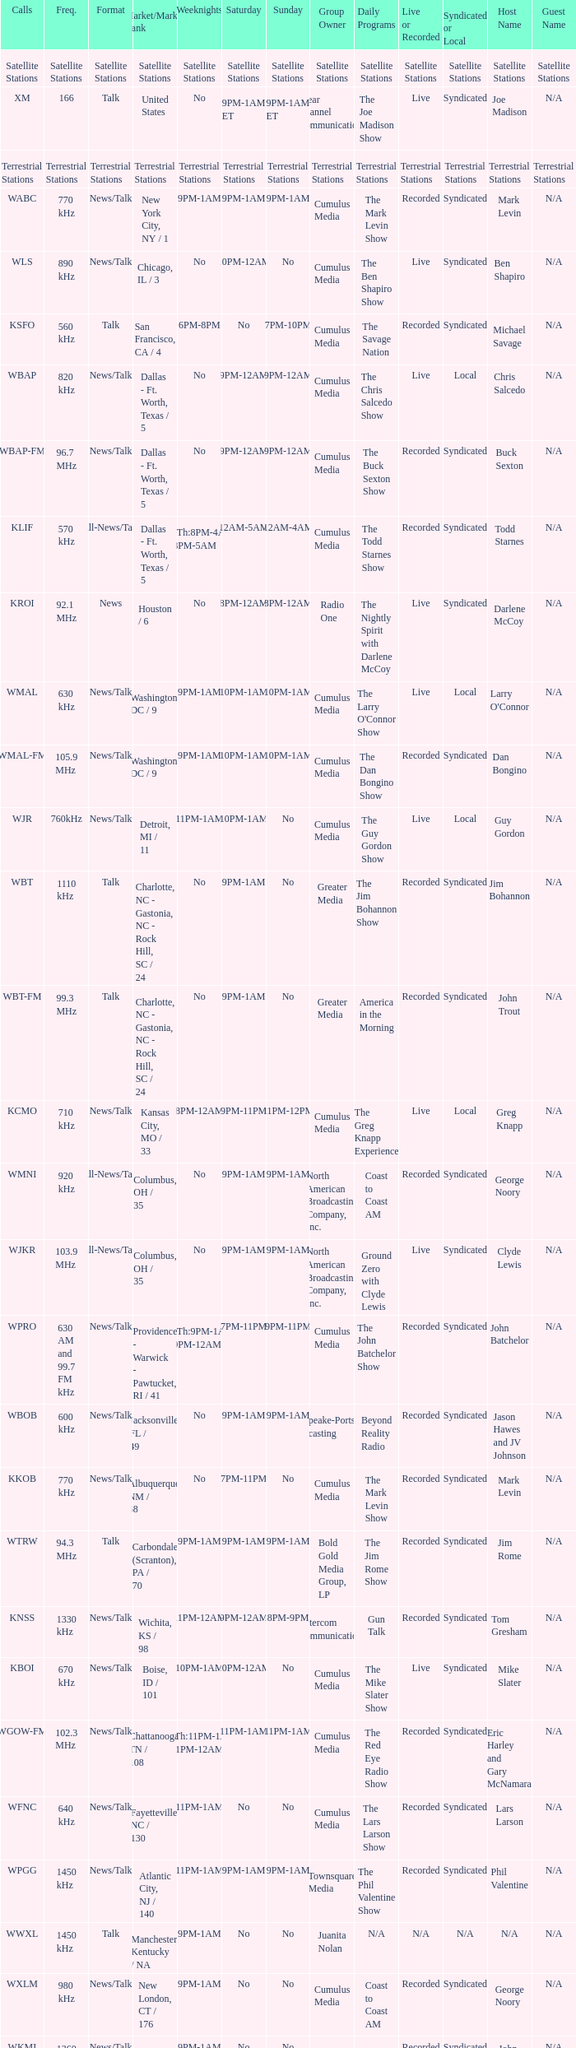What is the market for the 11pm-1am Saturday game? Chattanooga, TN / 108. 